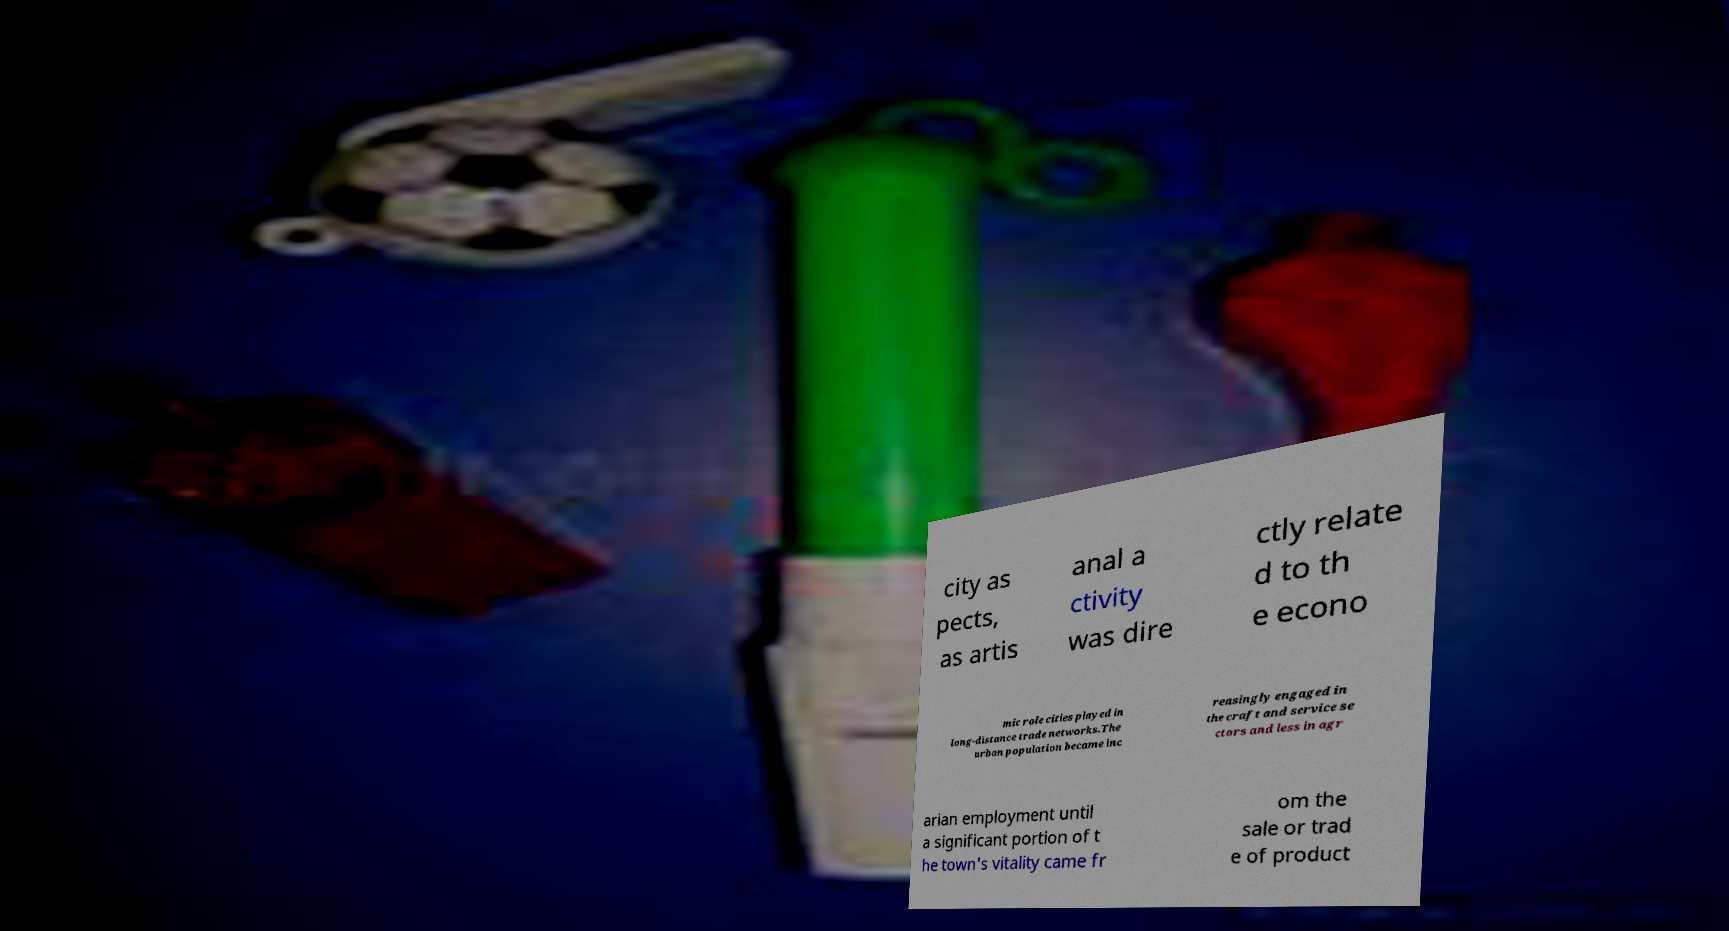Could you assist in decoding the text presented in this image and type it out clearly? city as pects, as artis anal a ctivity was dire ctly relate d to th e econo mic role cities played in long-distance trade networks.The urban population became inc reasingly engaged in the craft and service se ctors and less in agr arian employment until a significant portion of t he town's vitality came fr om the sale or trad e of product 